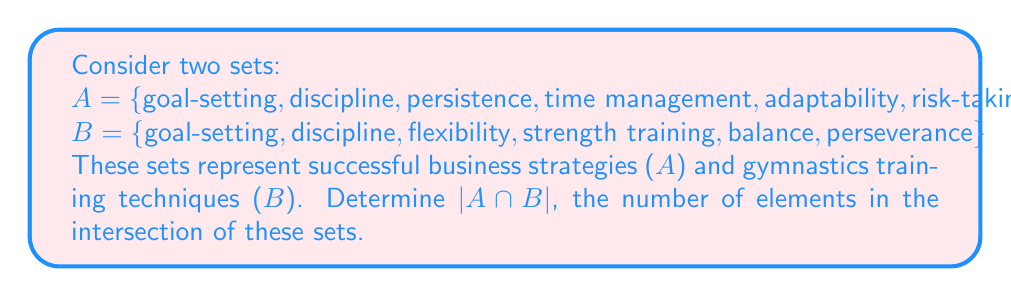Solve this math problem. To solve this problem, we need to follow these steps:

1. Identify the elements that are common to both sets A and B.
2. Count the number of these common elements.

Let's examine each element:

1. goal-setting: Present in both A and B
2. discipline: Present in both A and B
3. persistence: Present in A, but not in B
4. time management: Present in A, but not in B
5. adaptability: Present in A, but not in B
6. risk-taking: Present in A, but not in B
7. flexibility: Present in B, but not in A
8. strength training: Present in B, but not in A
9. balance: Present in B, but not in A
10. perseverance: Present in B, but not in A

The elements that appear in both sets are:
$A \cap B = \{goal-setting, discipline\}$

To find $|A \cap B|$, we simply count the number of elements in this intersection.

$$|A \cap B| = 2$$

This result shows that there are two strategies/techniques that are common to both successful business practices and gymnastics training, namely goal-setting and discipline. These shared elements reflect the persona's background as both an entrepreneur and a former gymnastics enthusiast, highlighting the transferable skills between the two domains.
Answer: $|A \cap B| = 2$ 